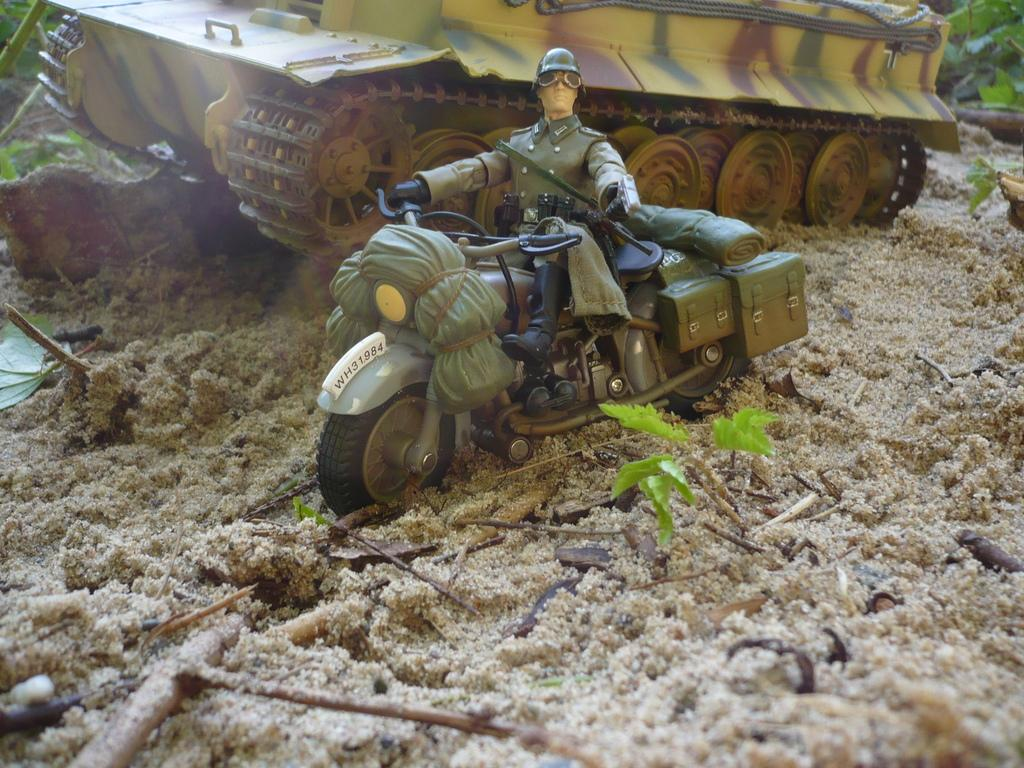What objects are present in the image? There are toys and small plants in the image. Where are the toys and small plants located? The toys and small plants are on the sand. Can you describe the setting of the image? The toys and small plants are on the sand, which suggests a beach or sandbox environment. What type of goat can be seen grazing near the toys and small plants in the image? There is no goat present in the image; it only features toys and small plants on the sand. 